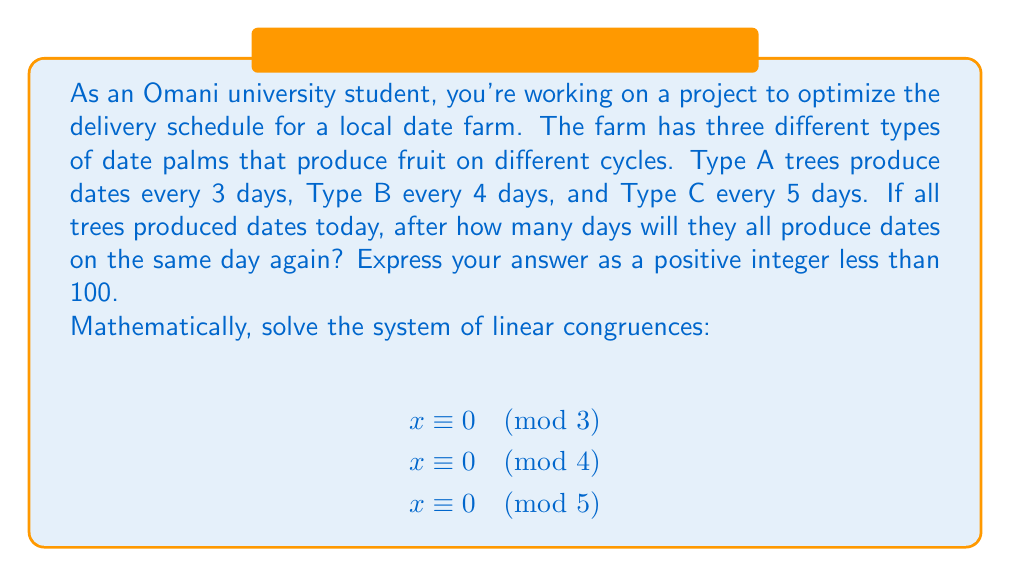Could you help me with this problem? To solve this system of linear congruences, we'll use the Chinese Remainder Theorem (CRT). Let's follow these steps:

1) First, calculate $M = m_1 \cdot m_2 \cdot m_3 = 3 \cdot 4 \cdot 5 = 60$.

2) For each congruence, calculate $M_i = M / m_i$:
   $M_1 = 60 / 3 = 20$
   $M_2 = 60 / 4 = 15$
   $M_3 = 60 / 5 = 12$

3) Find the modular multiplicative inverses:
   $20y_1 \equiv 1 \pmod{3} \implies y_1 = 2$
   $15y_2 \equiv 1 \pmod{4} \implies y_2 = 3$
   $12y_3 \equiv 1 \pmod{5} \implies y_3 = 3$

4) The solution is given by:
   $x = (a_1M_1y_1 + a_2M_2y_2 + a_3M_3y_3) \bmod M$

   Where $a_1 = a_2 = a_3 = 0$ (since all congruences are $\equiv 0$)

5) Therefore:
   $x = (0 \cdot 20 \cdot 2 + 0 \cdot 15 \cdot 3 + 0 \cdot 12 \cdot 3) \bmod 60 = 0$

6) Since we need a positive integer less than 100, and 0 is not positive, we add $M = 60$ to get our final answer:
   $x = 0 + 60 = 60$

Thus, all types of date palms will produce dates on the same day again after 60 days.
Answer: $60$ 